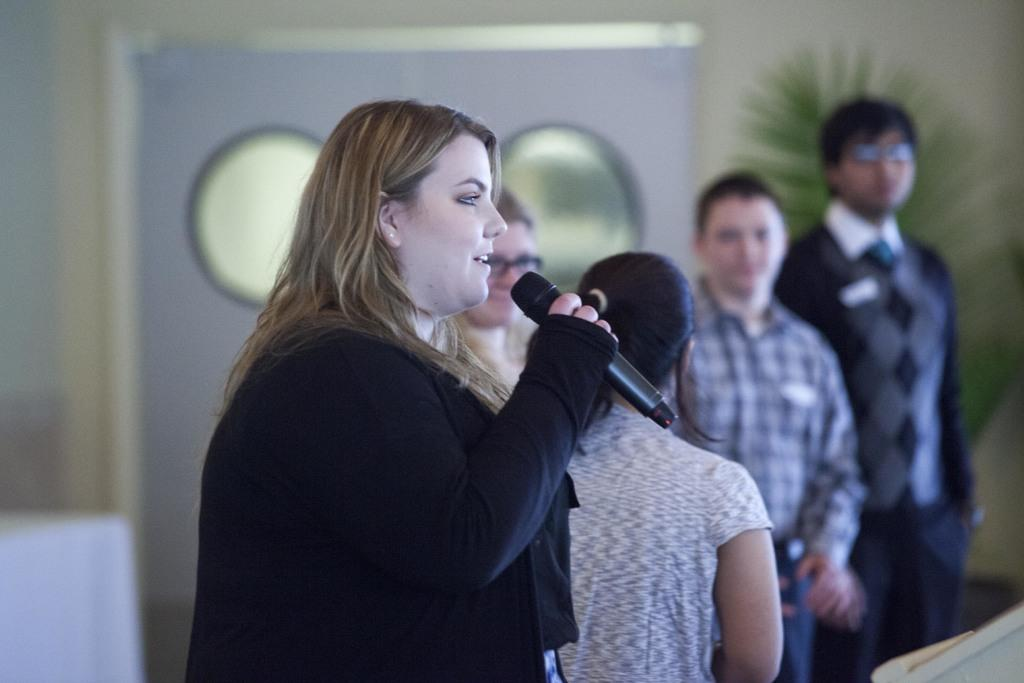How many people are in the image? There is a group of persons in the image. Can you describe the woman in the image? The woman is speaking in front of a microphone. What type of scale is the woman using to weigh the passengers in the image? There is no scale or passengers present in the image; the woman is speaking in front of a microphone. 